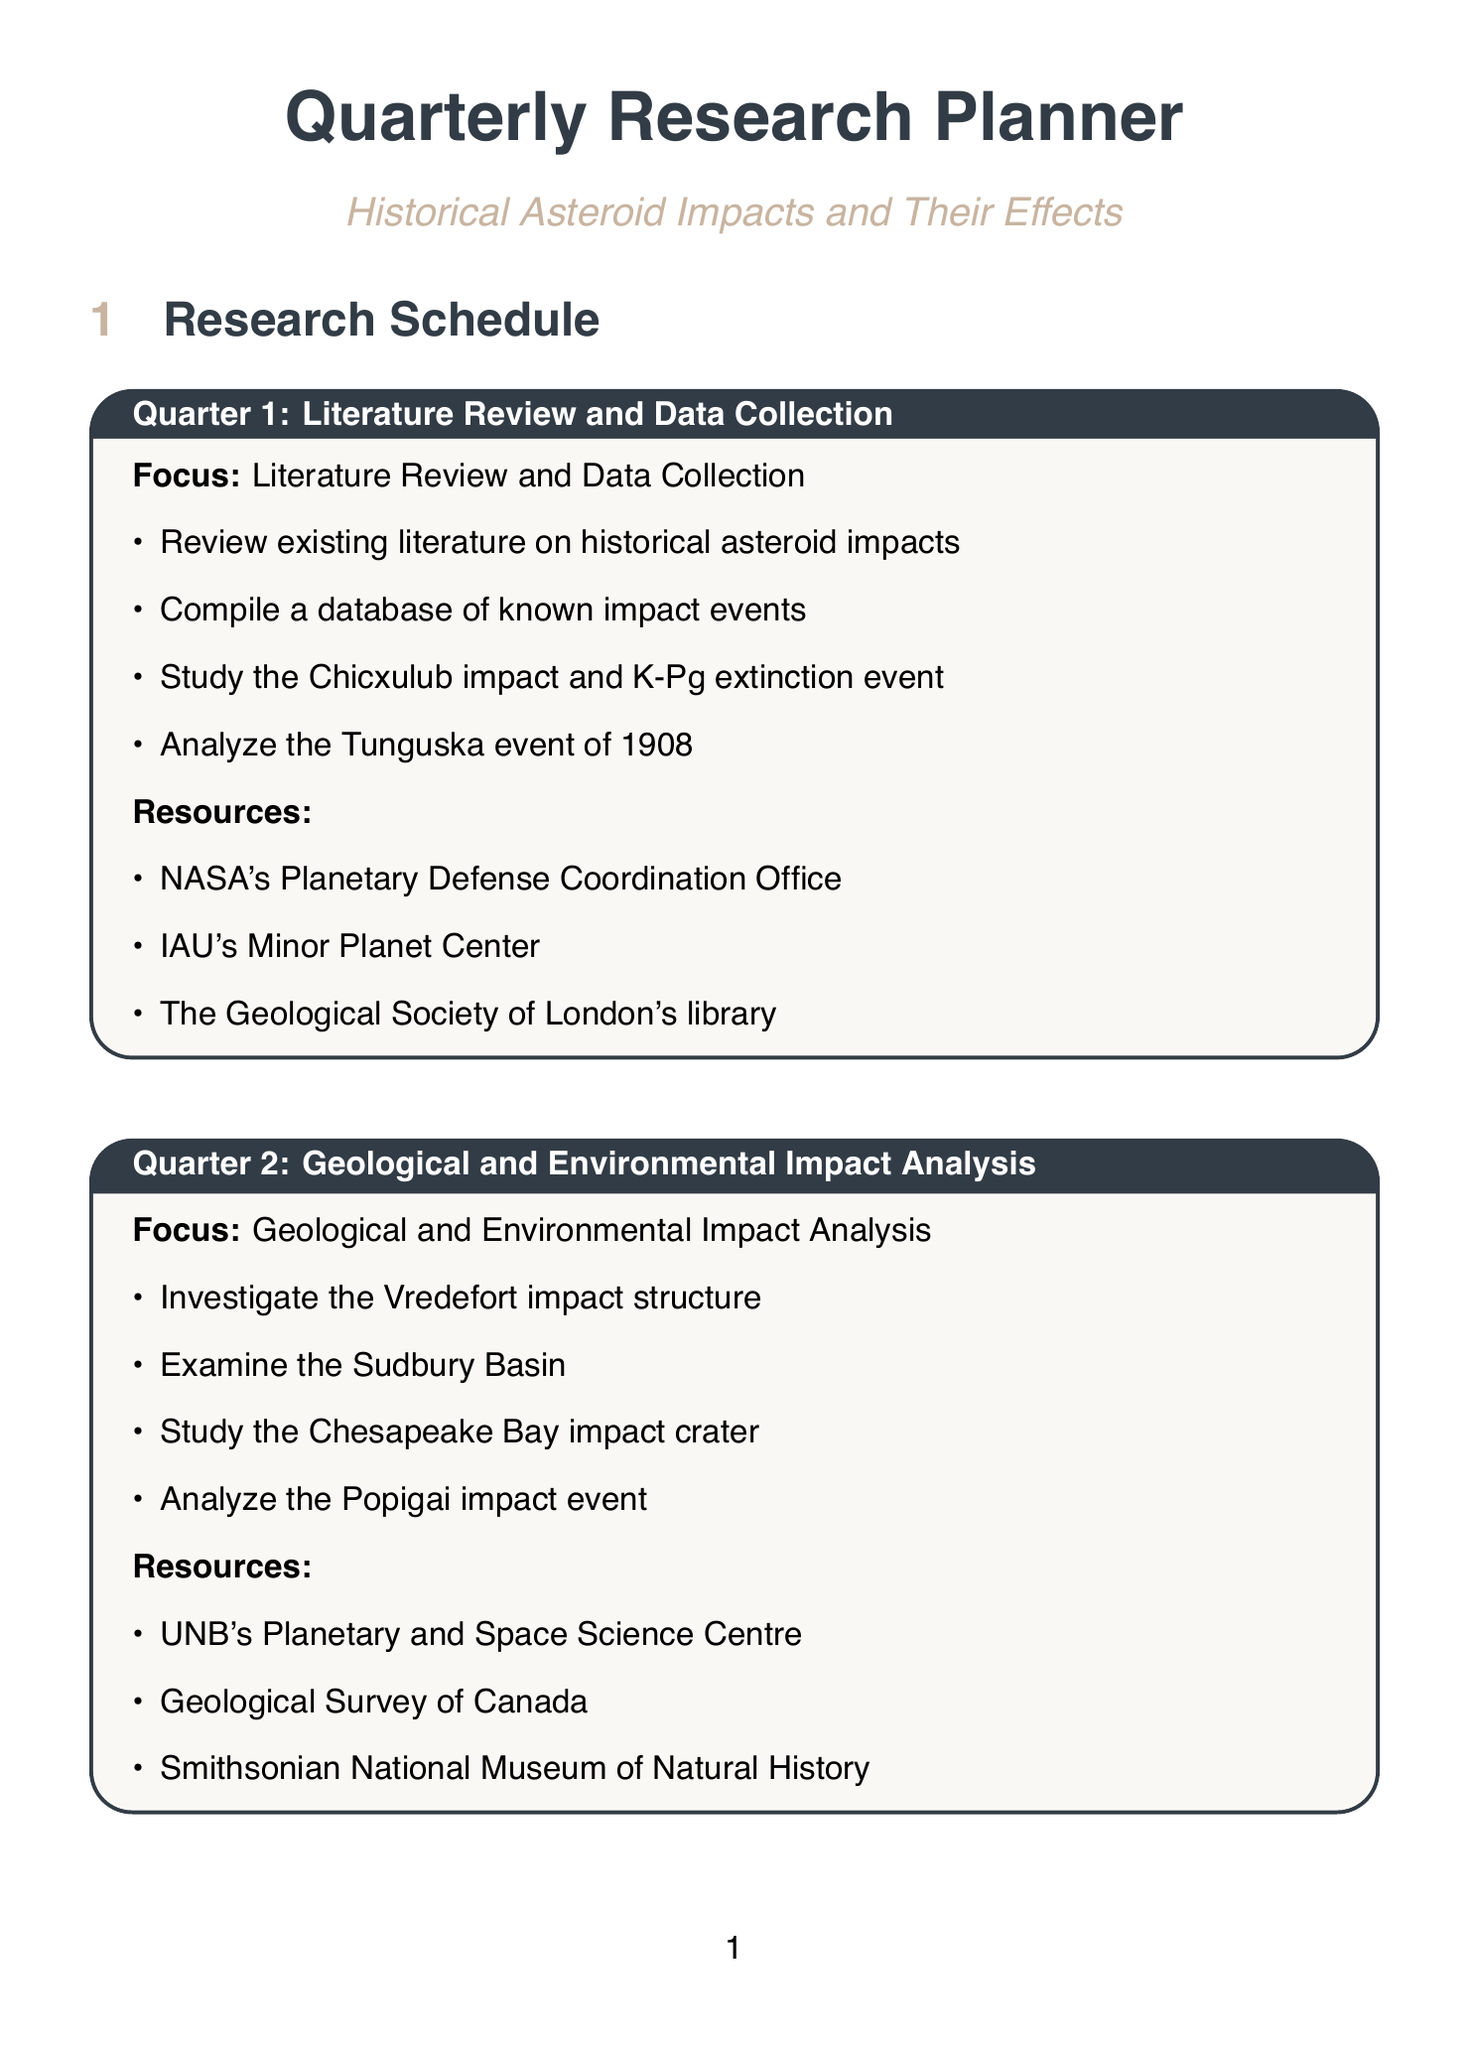What is the focus of Quarter 2? The document states that the focus of Quarter 2 is "Geological and Environmental Impact Analysis."
Answer: Geological and Environmental Impact Analysis How many activities are listed for Quarter 3? In the document, Quarter 3 contains four activities listed under "Societal and Cultural Impact Research."
Answer: 4 Which institution's library is a resource in Quarter 1? The resources listed in Quarter 1 include "The Geological Society of London's library."
Answer: The Geological Society of London's library What is one of the potential impact scenarios being developed in Quarter 4? The document mentions "99942 Apophis" as a potential impact scenario in Quarter 4.
Answer: 99942 Apophis What is the focus of Quarter 1? The document indicates that the focus of Quarter 1 is "Literature Review and Data Collection."
Answer: Literature Review and Data Collection Which database is mentioned as a source for compiling known impact events? The document refers to the "Earth Impact Database" as a source for compiling known impact events.
Answer: Earth Impact Database What year did the Tunguska event occur? The document states that the Tunguska event occurred in "1908."
Answer: 1908 What is the title of the document? The document is titled "Quarterly Research Planner."
Answer: Quarterly Research Planner 